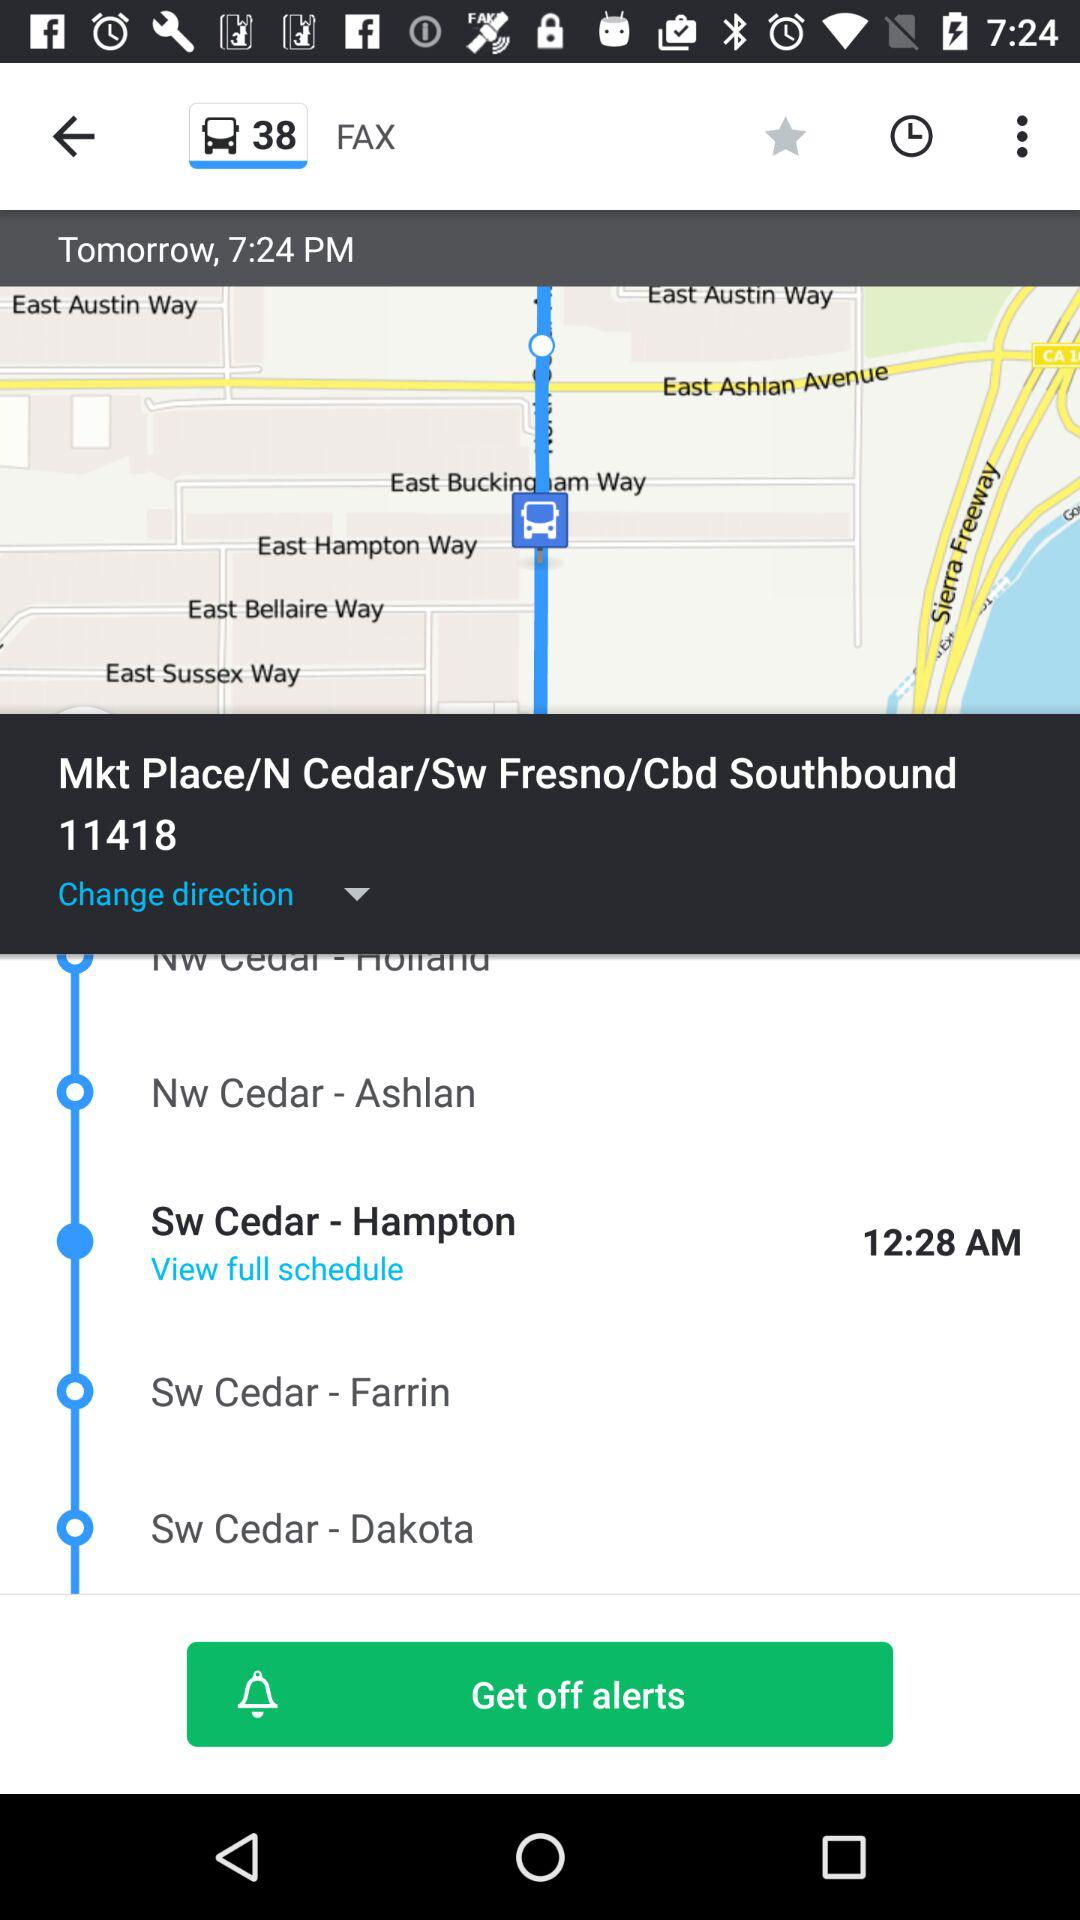What is the current address? The current address is Mkt Place/N Cedar/Sw Fresno/Cbd Southbound 11418. 